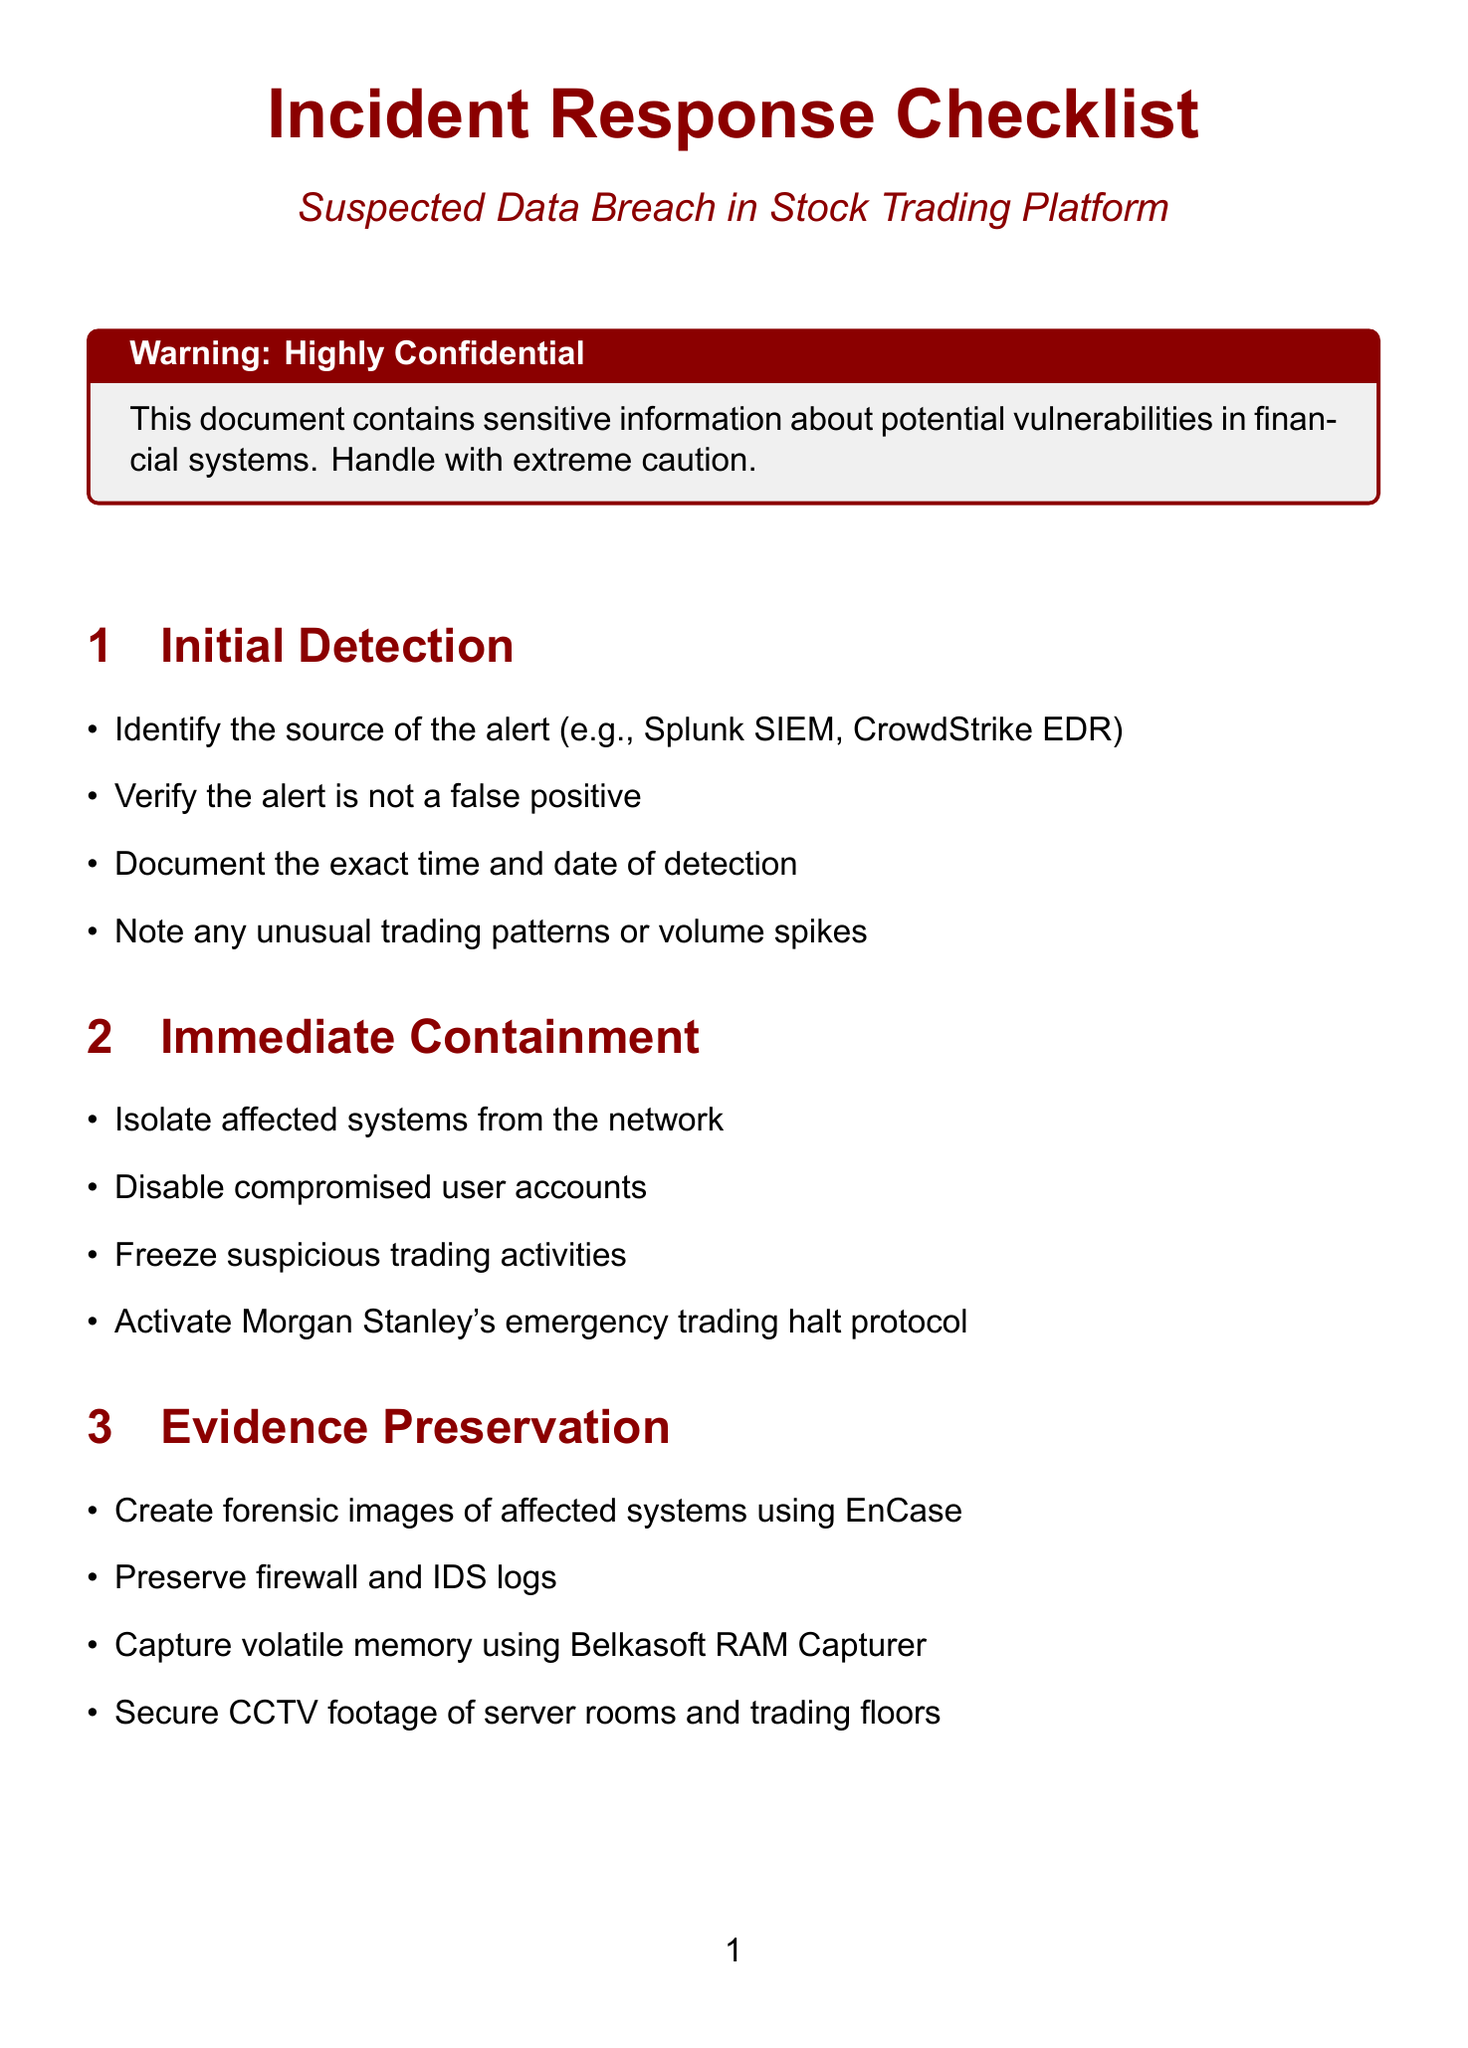What is the first step in the checklist? The first step in the checklist outlined in the document is "Initial Detection."
Answer: Initial Detection Which systems should be isolated during immediate containment? The document states to isolate affected systems from the network during immediate containment.
Answer: Affected systems Who should be notified according to the notification step? The document lists alerting the CISO and CTO as part of the notification actions.
Answer: CISO and CTO What tool is suggested for capturing volatile memory? The document recommends using Belkasoft RAM Capturer for capturing volatile memory.
Answer: Belkasoft RAM Capturer What should be prepared in recovery planning? According to the document, preparations should involve restoring systems from the last known clean backup.
Answer: Restore systems from last known clean backup What type of vulnerabilities is the vulnerability assessment focused on? The assessment particularly focuses on unpatched systems, especially in legacy trading platforms.
Answer: Unpatched systems How many actions are listed under evidence preservation? The document specifies four actions in the evidence preservation section.
Answer: Four actions Which algorithm's integrity should be verified in the system integrity verification step? The document mentions validating the integrity of high-frequency trading algorithms.
Answer: High-frequency trading algorithms What is the last step mentioned in the checklist? The final step outlined in the document is "Post-Incident Review."
Answer: Post-Incident Review 